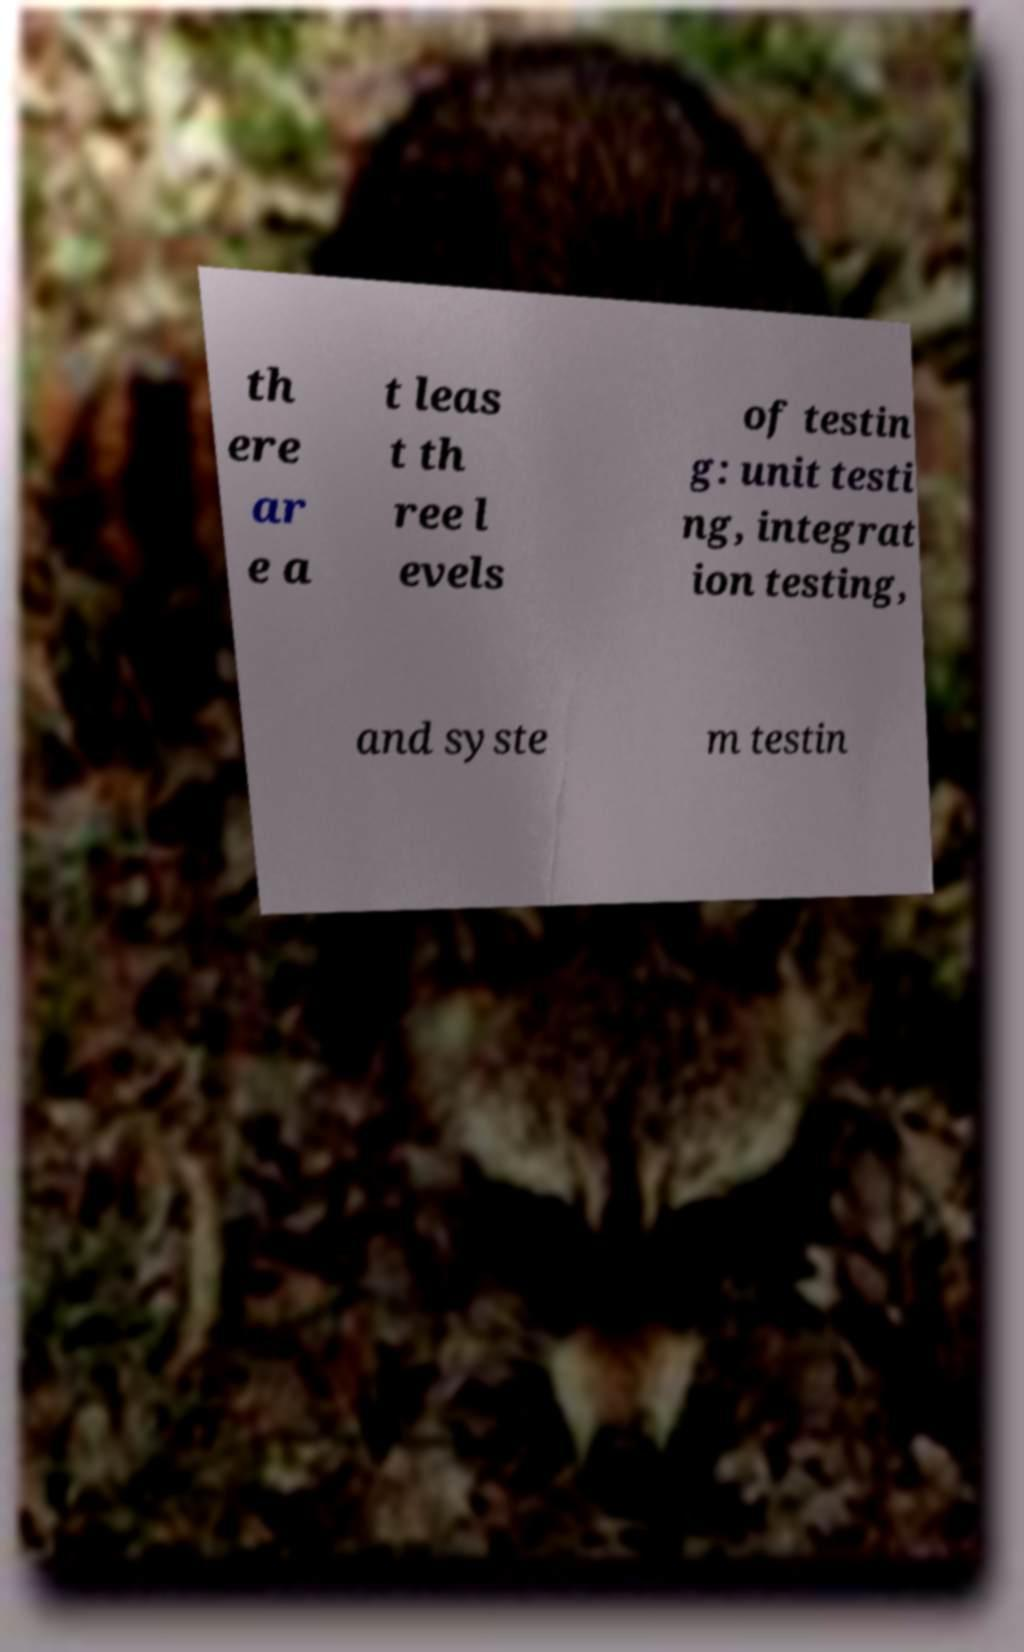I need the written content from this picture converted into text. Can you do that? th ere ar e a t leas t th ree l evels of testin g: unit testi ng, integrat ion testing, and syste m testin 